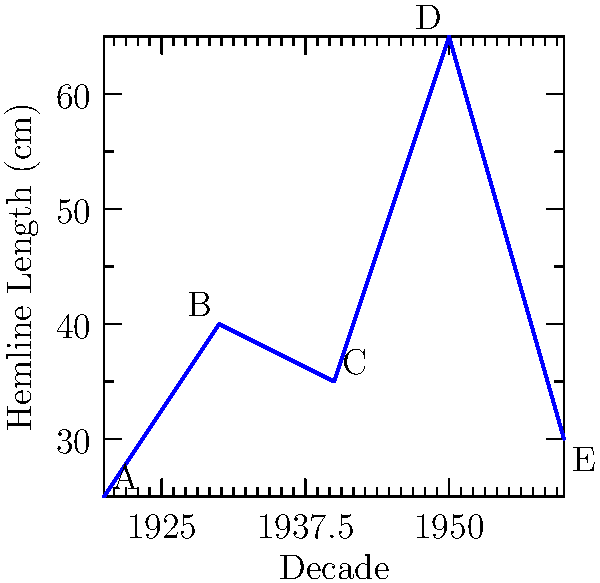Based on the graph showing hemline trends across decades, which era would be most appropriate for pairing a long pearl necklace with a vintage gown? To determine the most appropriate era for pairing a long pearl necklace with a vintage gown, we need to consider the hemline trends and typical fashion styles of each decade:

1. 1920s (Point A): Hemlines are shortest, indicating the flapper era. Short dresses were popular, often paired with long necklaces.
2. 1930s (Point B): Hemlines become longer, reflecting a more elegant and sophisticated style.
3. 1940s (Point C): Hemlines slightly shorter than the 1930s, but still relatively long due to wartime fabric restrictions.
4. 1950s (Point D): Longest hemlines, indicating full-skirted dresses popular in this era.
5. 1960s (Point E): Hemlines become shorter again, reflecting the mod style of the decade.

Long pearl necklaces were most iconic and widely worn in the 1920s, complementing the straight, short flapper dresses of the era. The graph shows the shortest hemlines for this decade, which aligns with the flapper style.

Therefore, the 1920s would be the most appropriate era for pairing a long pearl necklace with a vintage gown, as it was a defining accessory of that time period and perfectly matched the style of dresses worn then.
Answer: 1920s 